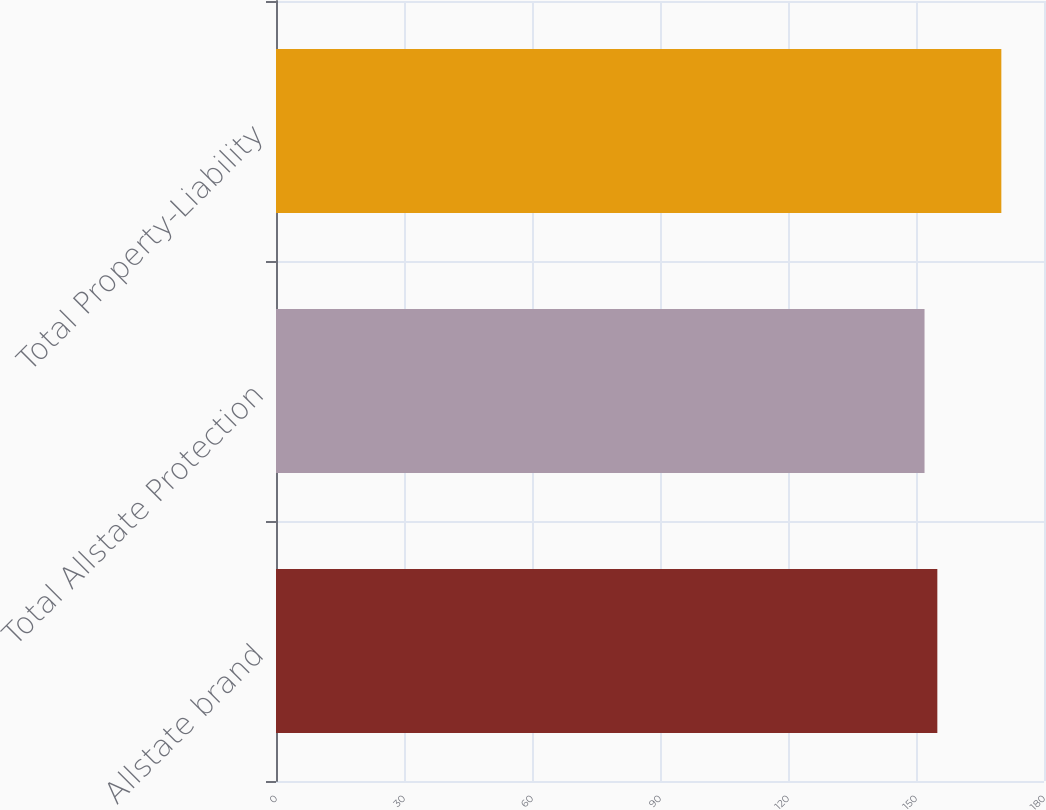<chart> <loc_0><loc_0><loc_500><loc_500><bar_chart><fcel>Allstate brand<fcel>Total Allstate Protection<fcel>Total Property-Liability<nl><fcel>155<fcel>152<fcel>170<nl></chart> 